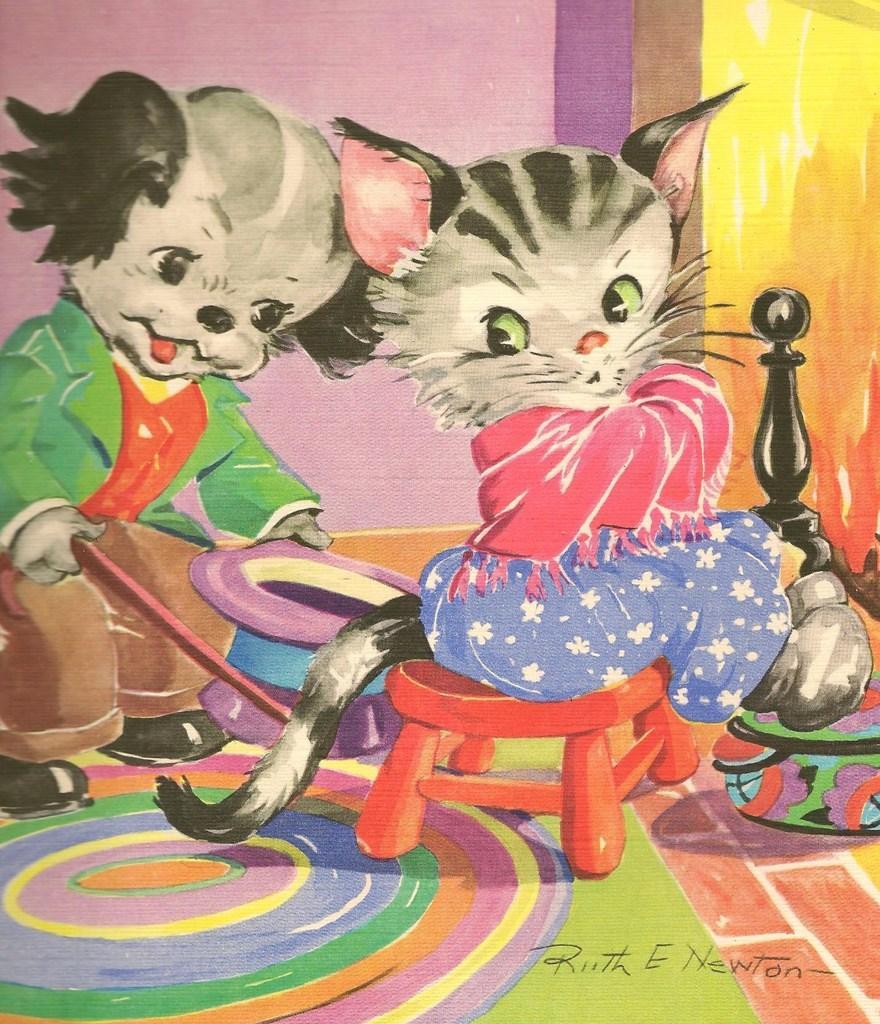Could you give a brief overview of what you see in this image? This is the painting were we can see one cat is sitting on stool, behind one more cat is standing by holding cap and stick in hand. The floor is colorful. 